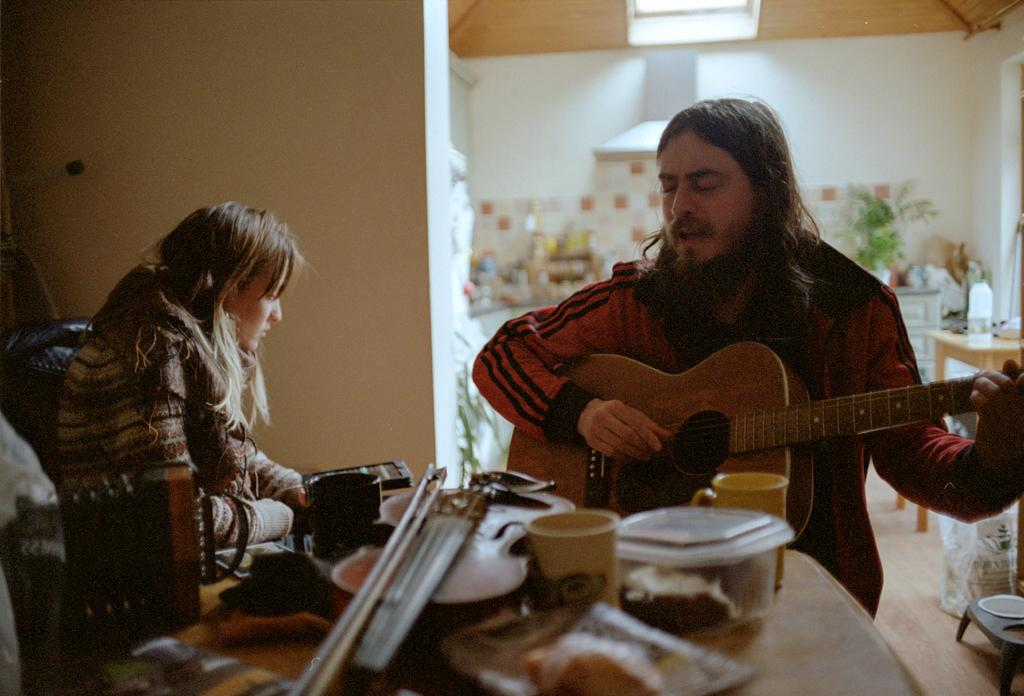How many people are in the image? There is a woman and a man in the image. What is the man doing in the image? The man is playing a guitar. What is on the table in the image? There are cups, boxes, and bowls on the table. What can be seen in the background of the image? There is a wall and a plant in the background of the image. What type of guide is the woman holding in the image? There is no guide present in the image. Is the man sleeping while playing the guitar in the image? No, the man is not sleeping; he is actively playing the guitar. 